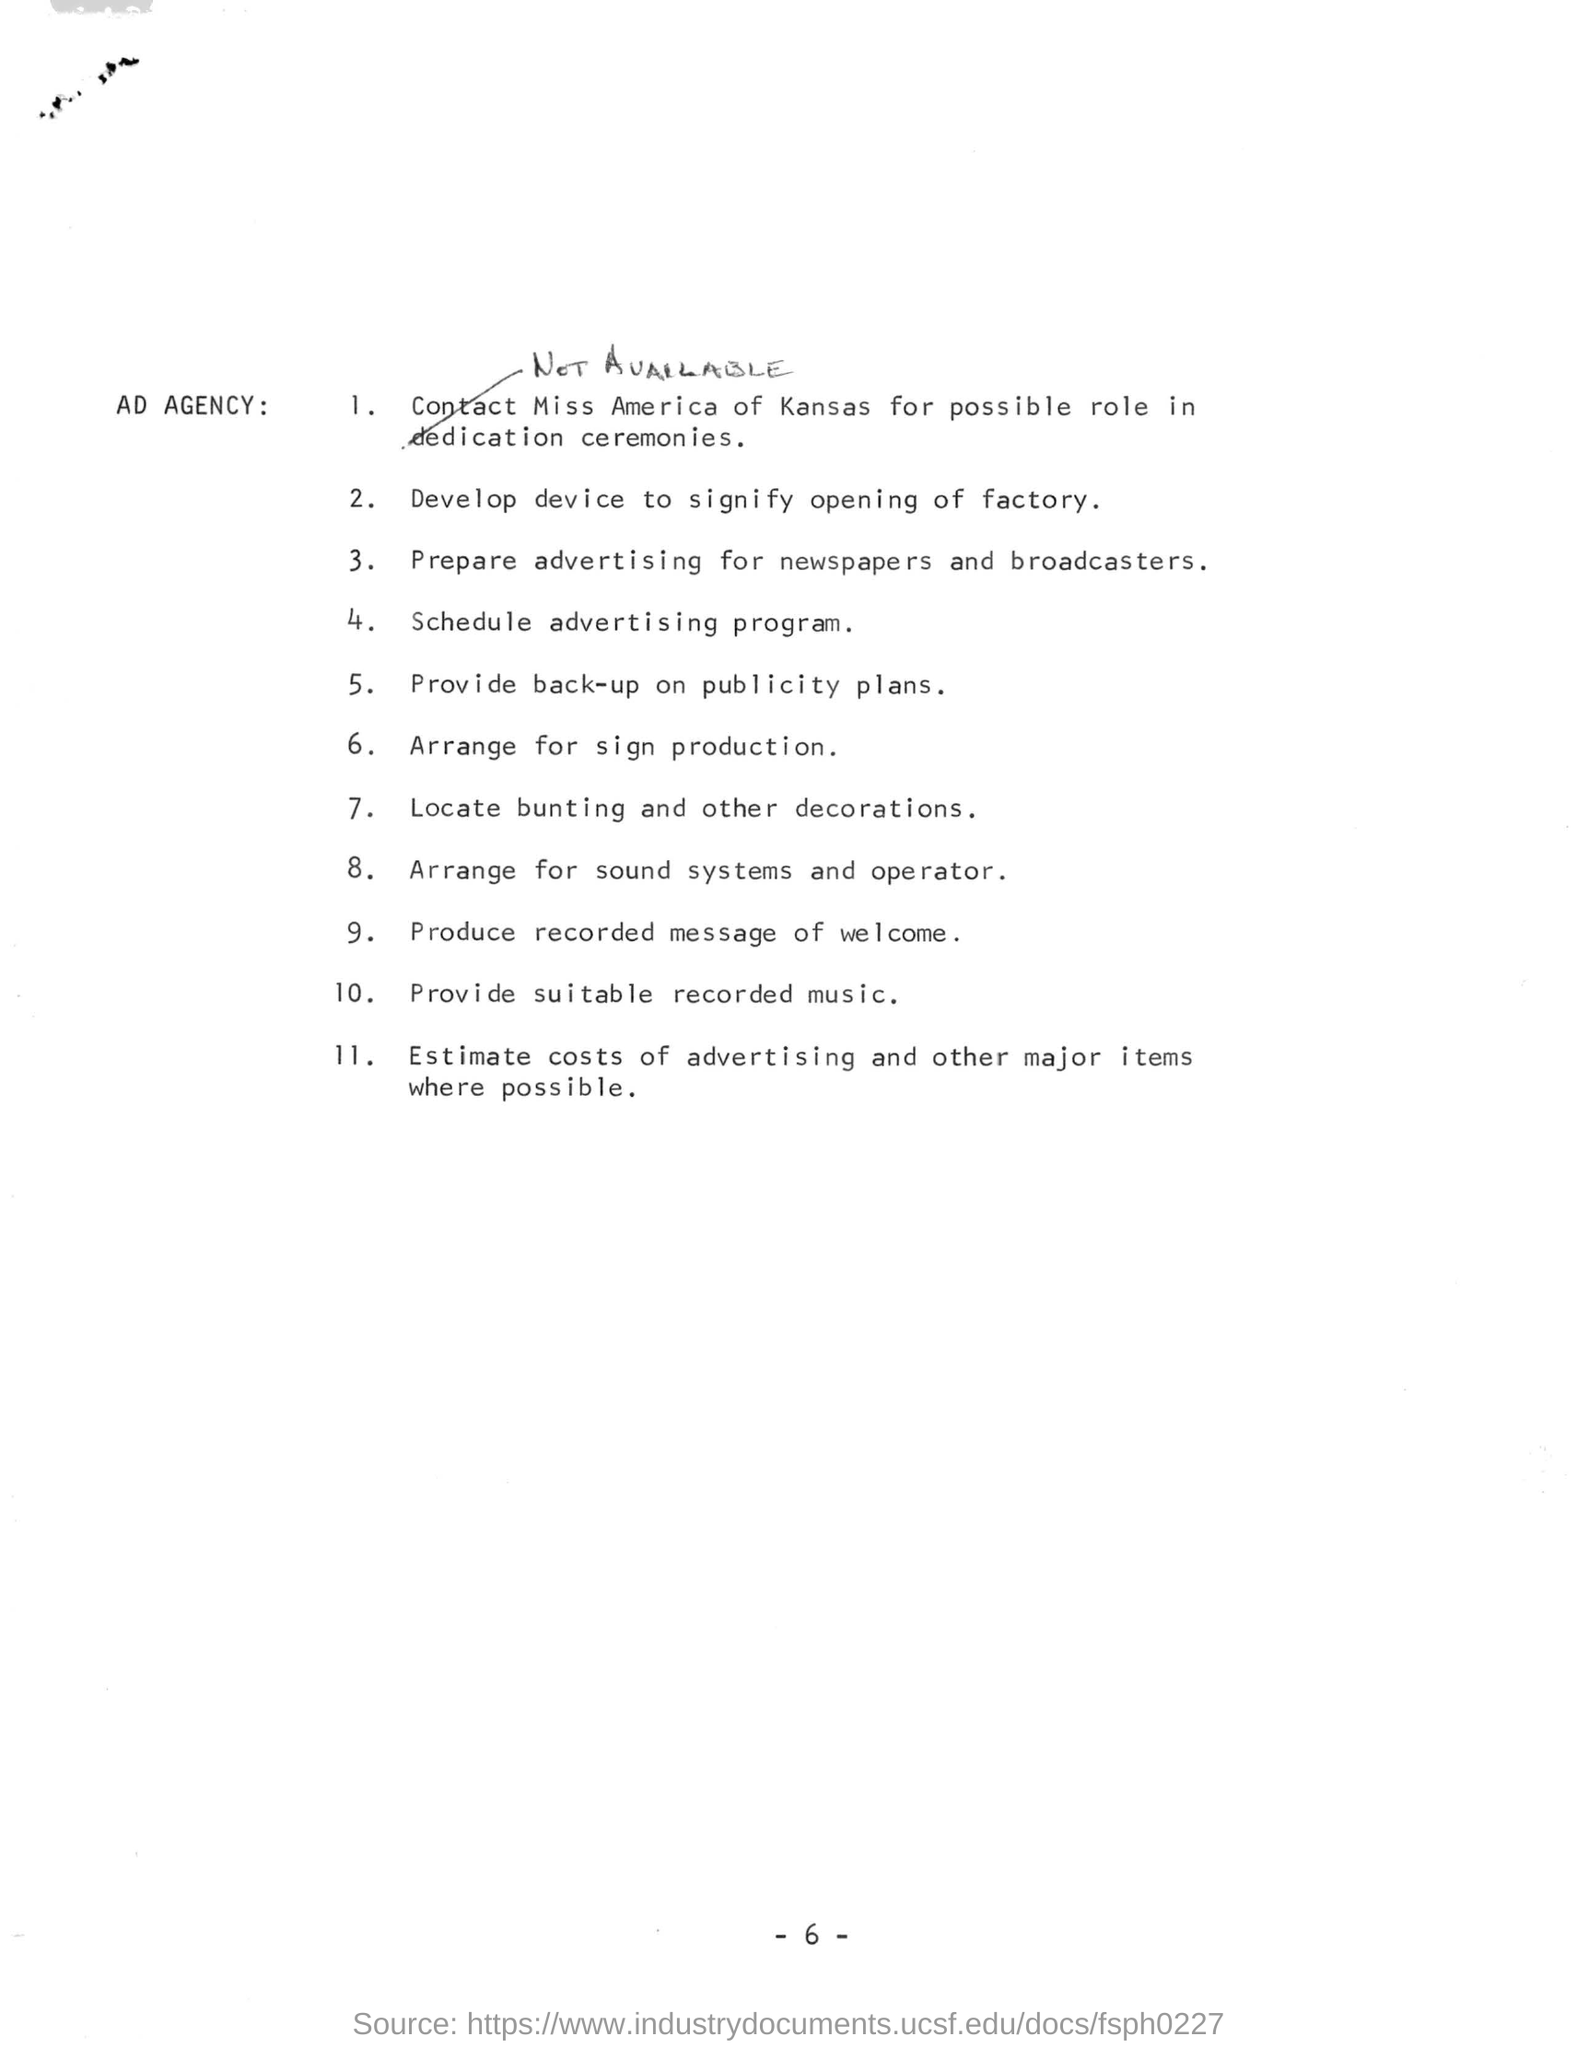List a handful of essential elements in this visual. The person who must be contacted for a role in dedication ceremonies is Miss America of Kansas. Point 10 in this list is "What is point 10. in this list? Provide suitable recorded music...". There are 11 points in the checklist. 